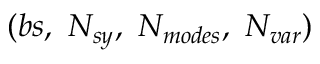Convert formula to latex. <formula><loc_0><loc_0><loc_500><loc_500>( b s , \ N _ { s y } , \ N _ { m o d e s } , \ N _ { v a r } )</formula> 